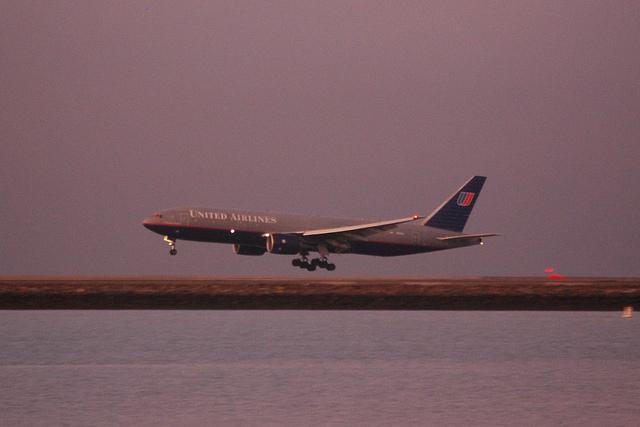What airline are they part of?
Concise answer only. United airlines. Is there police or security nearby?
Give a very brief answer. No. How can you tell the photo was taken from behind a window?
Quick response, please. Color. Are the planes about to land?
Write a very short answer. Yes. Will the plane land in the water?
Quick response, please. No. Does this plane fly overseas?
Short answer required. Yes. Does the plane belong to an American airline?
Short answer required. Yes. Is the sky clear?
Answer briefly. Yes. Is the plane high?
Quick response, please. No. What color is the plane?
Give a very brief answer. Gray. What word is on the plane?
Answer briefly. United airlines. What is the color of the plane?
Be succinct. Silver. Is the plane in flight?
Concise answer only. Yes. Is this picture in sepia tone?
Concise answer only. No. What color is the tail of the plane?
Answer briefly. Blue. What's natural landmark is in the background?
Quick response, please. Beach. Is the plane in motion?
Write a very short answer. Yes. Is the plane flying?
Write a very short answer. Yes. Is the plane flying across the sea?
Concise answer only. Yes. Is this a passenger plane?
Answer briefly. Yes. What is shown on the tail of this plane?
Short answer required. Logo. Is there a fence in the image?
Write a very short answer. No. What name is on top of the plane?
Give a very brief answer. United airlines. How many planes do you see?
Short answer required. 1. Is this plane in the air?
Concise answer only. Yes. How many airplanes are there?
Quick response, please. 1. How many buoys are pictured?
Quick response, please. 1. 